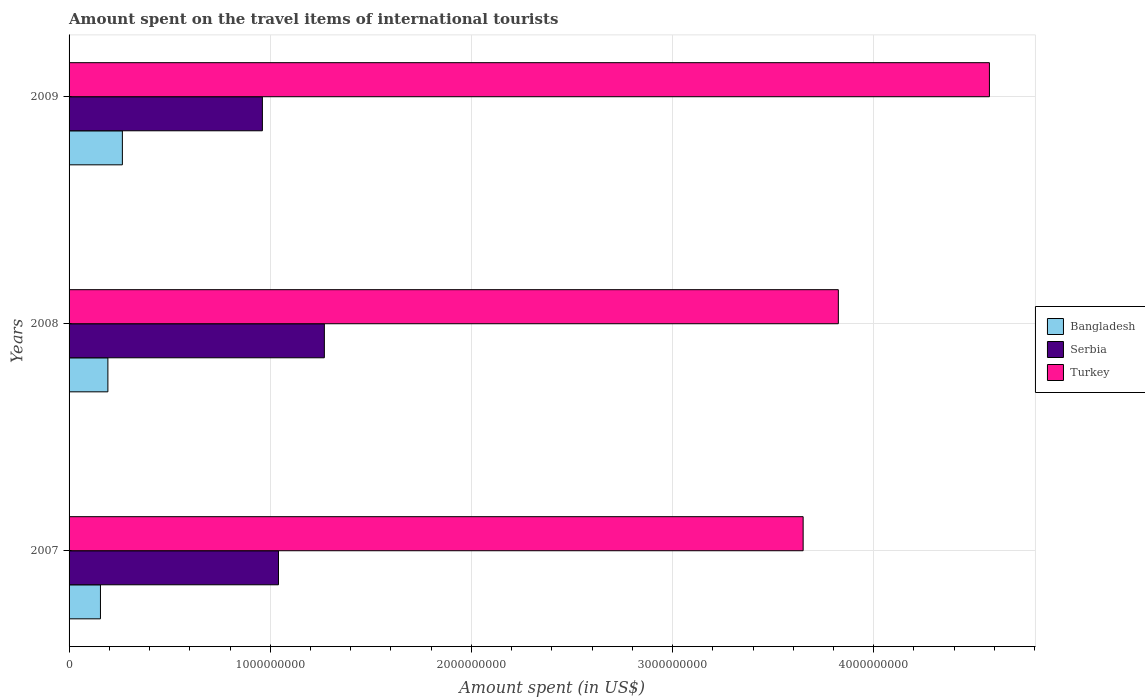How many groups of bars are there?
Keep it short and to the point. 3. Are the number of bars per tick equal to the number of legend labels?
Your response must be concise. Yes. Are the number of bars on each tick of the Y-axis equal?
Offer a very short reply. Yes. How many bars are there on the 2nd tick from the top?
Your answer should be compact. 3. What is the label of the 3rd group of bars from the top?
Provide a succinct answer. 2007. What is the amount spent on the travel items of international tourists in Bangladesh in 2007?
Keep it short and to the point. 1.56e+08. Across all years, what is the maximum amount spent on the travel items of international tourists in Bangladesh?
Provide a succinct answer. 2.65e+08. Across all years, what is the minimum amount spent on the travel items of international tourists in Bangladesh?
Keep it short and to the point. 1.56e+08. In which year was the amount spent on the travel items of international tourists in Bangladesh maximum?
Your answer should be very brief. 2009. What is the total amount spent on the travel items of international tourists in Turkey in the graph?
Keep it short and to the point. 1.20e+1. What is the difference between the amount spent on the travel items of international tourists in Bangladesh in 2007 and that in 2008?
Your response must be concise. -3.70e+07. What is the difference between the amount spent on the travel items of international tourists in Bangladesh in 2009 and the amount spent on the travel items of international tourists in Turkey in 2008?
Your answer should be compact. -3.56e+09. What is the average amount spent on the travel items of international tourists in Turkey per year?
Offer a very short reply. 4.02e+09. In the year 2007, what is the difference between the amount spent on the travel items of international tourists in Bangladesh and amount spent on the travel items of international tourists in Serbia?
Your answer should be compact. -8.85e+08. In how many years, is the amount spent on the travel items of international tourists in Serbia greater than 1400000000 US$?
Provide a succinct answer. 0. What is the ratio of the amount spent on the travel items of international tourists in Turkey in 2007 to that in 2009?
Your answer should be compact. 0.8. Is the difference between the amount spent on the travel items of international tourists in Bangladesh in 2007 and 2008 greater than the difference between the amount spent on the travel items of international tourists in Serbia in 2007 and 2008?
Your answer should be compact. Yes. What is the difference between the highest and the second highest amount spent on the travel items of international tourists in Serbia?
Make the answer very short. 2.28e+08. What is the difference between the highest and the lowest amount spent on the travel items of international tourists in Bangladesh?
Your answer should be compact. 1.09e+08. In how many years, is the amount spent on the travel items of international tourists in Turkey greater than the average amount spent on the travel items of international tourists in Turkey taken over all years?
Your answer should be compact. 1. Are all the bars in the graph horizontal?
Offer a very short reply. Yes. What is the difference between two consecutive major ticks on the X-axis?
Provide a succinct answer. 1.00e+09. Are the values on the major ticks of X-axis written in scientific E-notation?
Your answer should be compact. No. Does the graph contain any zero values?
Provide a succinct answer. No. Does the graph contain grids?
Give a very brief answer. Yes. Where does the legend appear in the graph?
Make the answer very short. Center right. How many legend labels are there?
Ensure brevity in your answer.  3. What is the title of the graph?
Offer a terse response. Amount spent on the travel items of international tourists. Does "United Arab Emirates" appear as one of the legend labels in the graph?
Offer a terse response. No. What is the label or title of the X-axis?
Keep it short and to the point. Amount spent (in US$). What is the Amount spent (in US$) in Bangladesh in 2007?
Offer a very short reply. 1.56e+08. What is the Amount spent (in US$) of Serbia in 2007?
Your response must be concise. 1.04e+09. What is the Amount spent (in US$) of Turkey in 2007?
Provide a short and direct response. 3.65e+09. What is the Amount spent (in US$) in Bangladesh in 2008?
Provide a succinct answer. 1.93e+08. What is the Amount spent (in US$) in Serbia in 2008?
Make the answer very short. 1.27e+09. What is the Amount spent (in US$) in Turkey in 2008?
Offer a very short reply. 3.82e+09. What is the Amount spent (in US$) in Bangladesh in 2009?
Make the answer very short. 2.65e+08. What is the Amount spent (in US$) in Serbia in 2009?
Give a very brief answer. 9.61e+08. What is the Amount spent (in US$) of Turkey in 2009?
Provide a short and direct response. 4.58e+09. Across all years, what is the maximum Amount spent (in US$) in Bangladesh?
Offer a terse response. 2.65e+08. Across all years, what is the maximum Amount spent (in US$) in Serbia?
Your answer should be compact. 1.27e+09. Across all years, what is the maximum Amount spent (in US$) in Turkey?
Offer a very short reply. 4.58e+09. Across all years, what is the minimum Amount spent (in US$) of Bangladesh?
Offer a very short reply. 1.56e+08. Across all years, what is the minimum Amount spent (in US$) in Serbia?
Your answer should be compact. 9.61e+08. Across all years, what is the minimum Amount spent (in US$) in Turkey?
Give a very brief answer. 3.65e+09. What is the total Amount spent (in US$) in Bangladesh in the graph?
Provide a short and direct response. 6.14e+08. What is the total Amount spent (in US$) of Serbia in the graph?
Your response must be concise. 3.27e+09. What is the total Amount spent (in US$) in Turkey in the graph?
Give a very brief answer. 1.20e+1. What is the difference between the Amount spent (in US$) in Bangladesh in 2007 and that in 2008?
Provide a short and direct response. -3.70e+07. What is the difference between the Amount spent (in US$) of Serbia in 2007 and that in 2008?
Make the answer very short. -2.28e+08. What is the difference between the Amount spent (in US$) of Turkey in 2007 and that in 2008?
Keep it short and to the point. -1.75e+08. What is the difference between the Amount spent (in US$) in Bangladesh in 2007 and that in 2009?
Provide a succinct answer. -1.09e+08. What is the difference between the Amount spent (in US$) of Serbia in 2007 and that in 2009?
Offer a very short reply. 8.00e+07. What is the difference between the Amount spent (in US$) in Turkey in 2007 and that in 2009?
Provide a short and direct response. -9.26e+08. What is the difference between the Amount spent (in US$) in Bangladesh in 2008 and that in 2009?
Provide a succinct answer. -7.20e+07. What is the difference between the Amount spent (in US$) of Serbia in 2008 and that in 2009?
Your answer should be compact. 3.08e+08. What is the difference between the Amount spent (in US$) in Turkey in 2008 and that in 2009?
Provide a short and direct response. -7.51e+08. What is the difference between the Amount spent (in US$) of Bangladesh in 2007 and the Amount spent (in US$) of Serbia in 2008?
Give a very brief answer. -1.11e+09. What is the difference between the Amount spent (in US$) of Bangladesh in 2007 and the Amount spent (in US$) of Turkey in 2008?
Give a very brief answer. -3.67e+09. What is the difference between the Amount spent (in US$) of Serbia in 2007 and the Amount spent (in US$) of Turkey in 2008?
Provide a short and direct response. -2.78e+09. What is the difference between the Amount spent (in US$) of Bangladesh in 2007 and the Amount spent (in US$) of Serbia in 2009?
Make the answer very short. -8.05e+08. What is the difference between the Amount spent (in US$) of Bangladesh in 2007 and the Amount spent (in US$) of Turkey in 2009?
Keep it short and to the point. -4.42e+09. What is the difference between the Amount spent (in US$) in Serbia in 2007 and the Amount spent (in US$) in Turkey in 2009?
Provide a short and direct response. -3.53e+09. What is the difference between the Amount spent (in US$) of Bangladesh in 2008 and the Amount spent (in US$) of Serbia in 2009?
Your answer should be very brief. -7.68e+08. What is the difference between the Amount spent (in US$) in Bangladesh in 2008 and the Amount spent (in US$) in Turkey in 2009?
Provide a succinct answer. -4.38e+09. What is the difference between the Amount spent (in US$) in Serbia in 2008 and the Amount spent (in US$) in Turkey in 2009?
Ensure brevity in your answer.  -3.31e+09. What is the average Amount spent (in US$) in Bangladesh per year?
Provide a succinct answer. 2.05e+08. What is the average Amount spent (in US$) of Serbia per year?
Provide a short and direct response. 1.09e+09. What is the average Amount spent (in US$) of Turkey per year?
Ensure brevity in your answer.  4.02e+09. In the year 2007, what is the difference between the Amount spent (in US$) in Bangladesh and Amount spent (in US$) in Serbia?
Your answer should be compact. -8.85e+08. In the year 2007, what is the difference between the Amount spent (in US$) in Bangladesh and Amount spent (in US$) in Turkey?
Offer a terse response. -3.49e+09. In the year 2007, what is the difference between the Amount spent (in US$) of Serbia and Amount spent (in US$) of Turkey?
Keep it short and to the point. -2.61e+09. In the year 2008, what is the difference between the Amount spent (in US$) of Bangladesh and Amount spent (in US$) of Serbia?
Your response must be concise. -1.08e+09. In the year 2008, what is the difference between the Amount spent (in US$) of Bangladesh and Amount spent (in US$) of Turkey?
Offer a very short reply. -3.63e+09. In the year 2008, what is the difference between the Amount spent (in US$) in Serbia and Amount spent (in US$) in Turkey?
Your answer should be compact. -2.56e+09. In the year 2009, what is the difference between the Amount spent (in US$) in Bangladesh and Amount spent (in US$) in Serbia?
Your response must be concise. -6.96e+08. In the year 2009, what is the difference between the Amount spent (in US$) in Bangladesh and Amount spent (in US$) in Turkey?
Offer a very short reply. -4.31e+09. In the year 2009, what is the difference between the Amount spent (in US$) in Serbia and Amount spent (in US$) in Turkey?
Make the answer very short. -3.61e+09. What is the ratio of the Amount spent (in US$) of Bangladesh in 2007 to that in 2008?
Your response must be concise. 0.81. What is the ratio of the Amount spent (in US$) of Serbia in 2007 to that in 2008?
Your response must be concise. 0.82. What is the ratio of the Amount spent (in US$) of Turkey in 2007 to that in 2008?
Provide a succinct answer. 0.95. What is the ratio of the Amount spent (in US$) in Bangladesh in 2007 to that in 2009?
Provide a short and direct response. 0.59. What is the ratio of the Amount spent (in US$) of Serbia in 2007 to that in 2009?
Your answer should be compact. 1.08. What is the ratio of the Amount spent (in US$) in Turkey in 2007 to that in 2009?
Offer a very short reply. 0.8. What is the ratio of the Amount spent (in US$) in Bangladesh in 2008 to that in 2009?
Your response must be concise. 0.73. What is the ratio of the Amount spent (in US$) of Serbia in 2008 to that in 2009?
Provide a short and direct response. 1.32. What is the ratio of the Amount spent (in US$) of Turkey in 2008 to that in 2009?
Make the answer very short. 0.84. What is the difference between the highest and the second highest Amount spent (in US$) in Bangladesh?
Offer a terse response. 7.20e+07. What is the difference between the highest and the second highest Amount spent (in US$) of Serbia?
Your answer should be very brief. 2.28e+08. What is the difference between the highest and the second highest Amount spent (in US$) of Turkey?
Give a very brief answer. 7.51e+08. What is the difference between the highest and the lowest Amount spent (in US$) of Bangladesh?
Ensure brevity in your answer.  1.09e+08. What is the difference between the highest and the lowest Amount spent (in US$) in Serbia?
Your response must be concise. 3.08e+08. What is the difference between the highest and the lowest Amount spent (in US$) in Turkey?
Provide a short and direct response. 9.26e+08. 